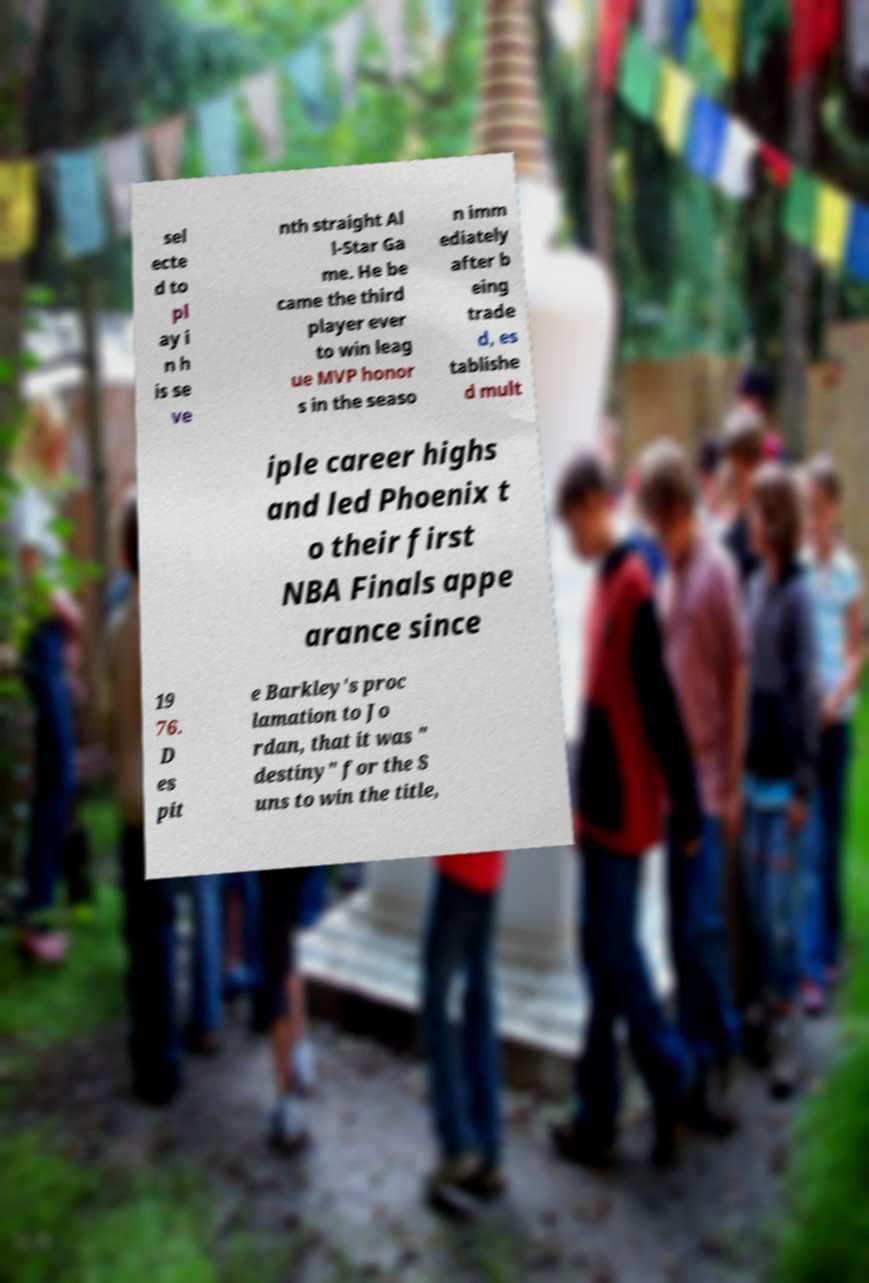I need the written content from this picture converted into text. Can you do that? sel ecte d to pl ay i n h is se ve nth straight Al l-Star Ga me. He be came the third player ever to win leag ue MVP honor s in the seaso n imm ediately after b eing trade d, es tablishe d mult iple career highs and led Phoenix t o their first NBA Finals appe arance since 19 76. D es pit e Barkley's proc lamation to Jo rdan, that it was " destiny" for the S uns to win the title, 